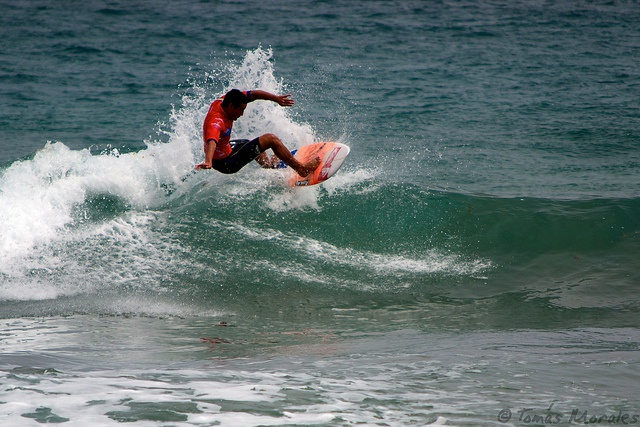Describe the objects in this image and their specific colors. I can see people in blue, black, maroon, and darkgray tones and surfboard in blue, lightpink, darkgray, salmon, and brown tones in this image. 